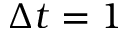Convert formula to latex. <formula><loc_0><loc_0><loc_500><loc_500>\Delta t = 1</formula> 